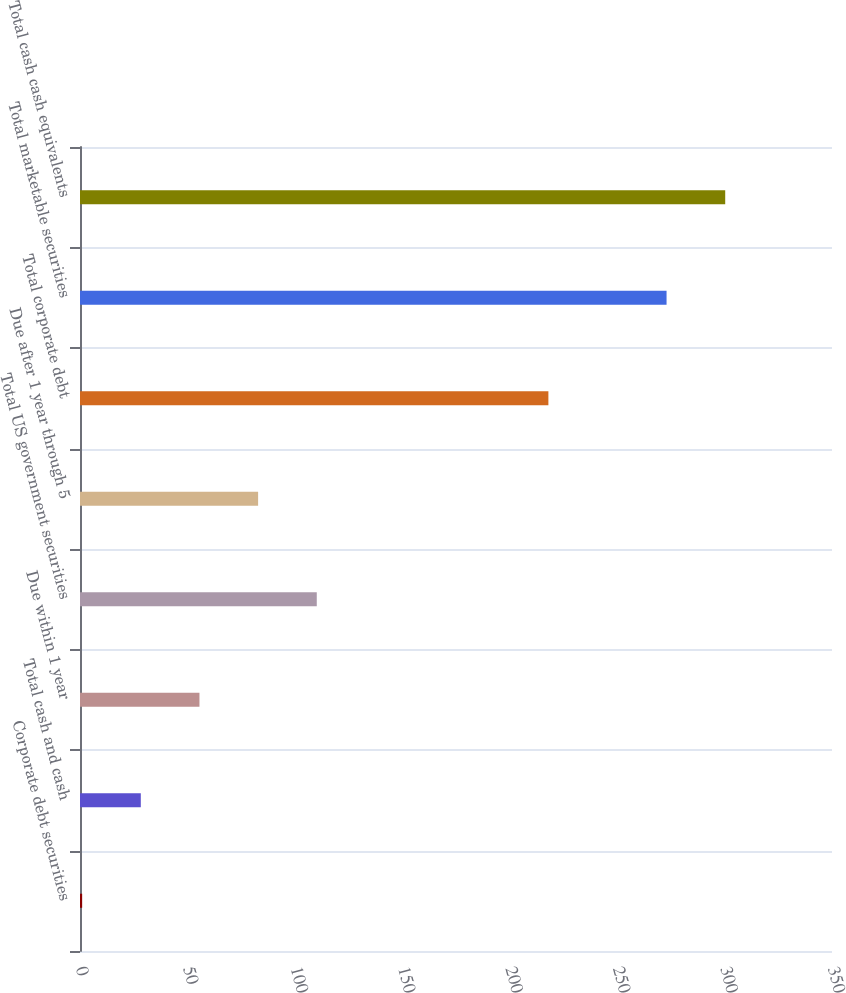<chart> <loc_0><loc_0><loc_500><loc_500><bar_chart><fcel>Corporate debt securities<fcel>Total cash and cash<fcel>Due within 1 year<fcel>Total US government securities<fcel>Due after 1 year through 5<fcel>Total corporate debt<fcel>Total marketable securities<fcel>Total cash cash equivalents<nl><fcel>1<fcel>28.3<fcel>55.6<fcel>110.2<fcel>82.9<fcel>218<fcel>273<fcel>300.3<nl></chart> 